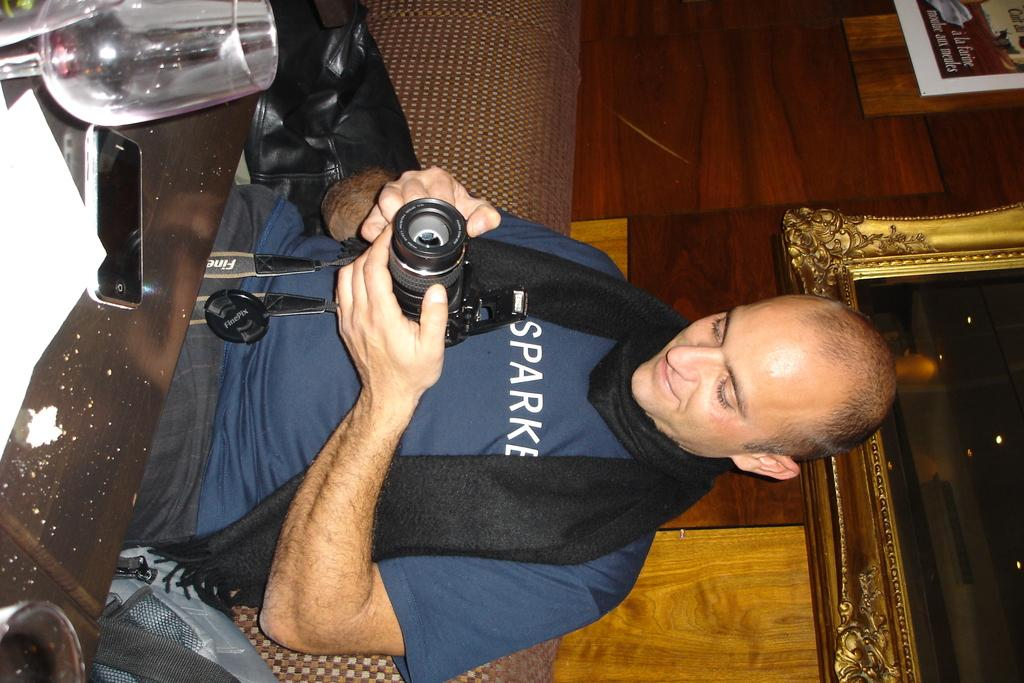What is the man in the image doing? The man is seated in the image and holding a camera in his hand. What other objects can be seen on the table in the image? There is a mobile phone, a paper, and a wine glass on the table. What might the man be planning to do with the camera? The man might be planning to take photos or record a video with the camera. What type of throat medicine is the man taking in the image? There is no indication of any throat medicine or any medical condition in the image. 